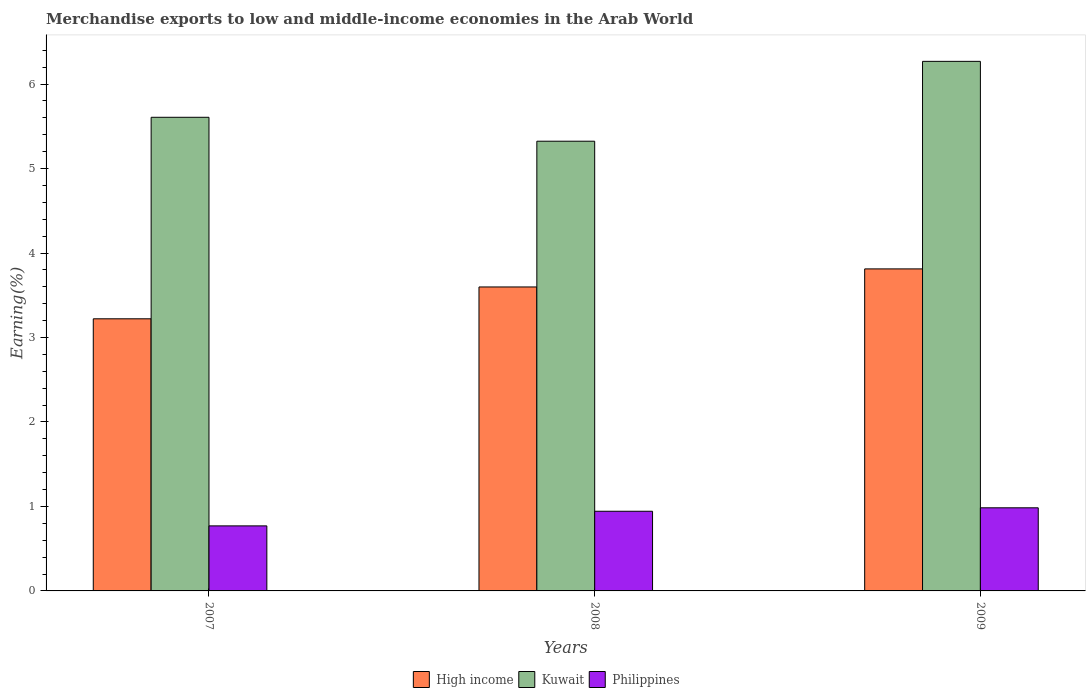How many groups of bars are there?
Provide a short and direct response. 3. How many bars are there on the 3rd tick from the left?
Give a very brief answer. 3. What is the percentage of amount earned from merchandise exports in Philippines in 2008?
Your answer should be compact. 0.94. Across all years, what is the maximum percentage of amount earned from merchandise exports in High income?
Keep it short and to the point. 3.81. Across all years, what is the minimum percentage of amount earned from merchandise exports in High income?
Offer a very short reply. 3.22. In which year was the percentage of amount earned from merchandise exports in High income maximum?
Give a very brief answer. 2009. In which year was the percentage of amount earned from merchandise exports in High income minimum?
Make the answer very short. 2007. What is the total percentage of amount earned from merchandise exports in Philippines in the graph?
Your response must be concise. 2.7. What is the difference between the percentage of amount earned from merchandise exports in Kuwait in 2008 and that in 2009?
Keep it short and to the point. -0.95. What is the difference between the percentage of amount earned from merchandise exports in High income in 2007 and the percentage of amount earned from merchandise exports in Kuwait in 2009?
Your answer should be compact. -3.05. What is the average percentage of amount earned from merchandise exports in Philippines per year?
Make the answer very short. 0.9. In the year 2009, what is the difference between the percentage of amount earned from merchandise exports in Kuwait and percentage of amount earned from merchandise exports in High income?
Keep it short and to the point. 2.46. What is the ratio of the percentage of amount earned from merchandise exports in Philippines in 2008 to that in 2009?
Provide a succinct answer. 0.96. Is the difference between the percentage of amount earned from merchandise exports in Kuwait in 2007 and 2009 greater than the difference between the percentage of amount earned from merchandise exports in High income in 2007 and 2009?
Your answer should be very brief. No. What is the difference between the highest and the second highest percentage of amount earned from merchandise exports in Kuwait?
Offer a very short reply. 0.66. What is the difference between the highest and the lowest percentage of amount earned from merchandise exports in Philippines?
Give a very brief answer. 0.21. In how many years, is the percentage of amount earned from merchandise exports in High income greater than the average percentage of amount earned from merchandise exports in High income taken over all years?
Provide a short and direct response. 2. What does the 2nd bar from the right in 2009 represents?
Ensure brevity in your answer.  Kuwait. How many bars are there?
Ensure brevity in your answer.  9. Does the graph contain grids?
Ensure brevity in your answer.  No. How many legend labels are there?
Your answer should be very brief. 3. What is the title of the graph?
Keep it short and to the point. Merchandise exports to low and middle-income economies in the Arab World. What is the label or title of the Y-axis?
Your response must be concise. Earning(%). What is the Earning(%) of High income in 2007?
Provide a short and direct response. 3.22. What is the Earning(%) of Kuwait in 2007?
Give a very brief answer. 5.61. What is the Earning(%) of Philippines in 2007?
Keep it short and to the point. 0.77. What is the Earning(%) of High income in 2008?
Provide a short and direct response. 3.6. What is the Earning(%) in Kuwait in 2008?
Your response must be concise. 5.32. What is the Earning(%) of Philippines in 2008?
Your response must be concise. 0.94. What is the Earning(%) in High income in 2009?
Provide a short and direct response. 3.81. What is the Earning(%) of Kuwait in 2009?
Make the answer very short. 6.27. What is the Earning(%) of Philippines in 2009?
Make the answer very short. 0.98. Across all years, what is the maximum Earning(%) of High income?
Offer a terse response. 3.81. Across all years, what is the maximum Earning(%) in Kuwait?
Your response must be concise. 6.27. Across all years, what is the maximum Earning(%) of Philippines?
Provide a succinct answer. 0.98. Across all years, what is the minimum Earning(%) of High income?
Provide a short and direct response. 3.22. Across all years, what is the minimum Earning(%) of Kuwait?
Your answer should be compact. 5.32. Across all years, what is the minimum Earning(%) in Philippines?
Provide a short and direct response. 0.77. What is the total Earning(%) in High income in the graph?
Provide a short and direct response. 10.63. What is the total Earning(%) in Kuwait in the graph?
Make the answer very short. 17.2. What is the total Earning(%) in Philippines in the graph?
Your response must be concise. 2.7. What is the difference between the Earning(%) of High income in 2007 and that in 2008?
Offer a very short reply. -0.38. What is the difference between the Earning(%) in Kuwait in 2007 and that in 2008?
Your answer should be very brief. 0.28. What is the difference between the Earning(%) of Philippines in 2007 and that in 2008?
Give a very brief answer. -0.17. What is the difference between the Earning(%) of High income in 2007 and that in 2009?
Your answer should be compact. -0.59. What is the difference between the Earning(%) in Kuwait in 2007 and that in 2009?
Offer a very short reply. -0.66. What is the difference between the Earning(%) in Philippines in 2007 and that in 2009?
Provide a short and direct response. -0.21. What is the difference between the Earning(%) in High income in 2008 and that in 2009?
Provide a succinct answer. -0.21. What is the difference between the Earning(%) of Kuwait in 2008 and that in 2009?
Your answer should be very brief. -0.95. What is the difference between the Earning(%) in Philippines in 2008 and that in 2009?
Your response must be concise. -0.04. What is the difference between the Earning(%) in High income in 2007 and the Earning(%) in Kuwait in 2008?
Give a very brief answer. -2.1. What is the difference between the Earning(%) in High income in 2007 and the Earning(%) in Philippines in 2008?
Provide a succinct answer. 2.28. What is the difference between the Earning(%) of Kuwait in 2007 and the Earning(%) of Philippines in 2008?
Offer a terse response. 4.66. What is the difference between the Earning(%) of High income in 2007 and the Earning(%) of Kuwait in 2009?
Your answer should be very brief. -3.05. What is the difference between the Earning(%) of High income in 2007 and the Earning(%) of Philippines in 2009?
Your answer should be compact. 2.24. What is the difference between the Earning(%) of Kuwait in 2007 and the Earning(%) of Philippines in 2009?
Your response must be concise. 4.62. What is the difference between the Earning(%) of High income in 2008 and the Earning(%) of Kuwait in 2009?
Give a very brief answer. -2.67. What is the difference between the Earning(%) of High income in 2008 and the Earning(%) of Philippines in 2009?
Keep it short and to the point. 2.61. What is the difference between the Earning(%) in Kuwait in 2008 and the Earning(%) in Philippines in 2009?
Provide a succinct answer. 4.34. What is the average Earning(%) in High income per year?
Your answer should be compact. 3.54. What is the average Earning(%) of Kuwait per year?
Your response must be concise. 5.73. What is the average Earning(%) in Philippines per year?
Your response must be concise. 0.9. In the year 2007, what is the difference between the Earning(%) in High income and Earning(%) in Kuwait?
Your response must be concise. -2.39. In the year 2007, what is the difference between the Earning(%) in High income and Earning(%) in Philippines?
Keep it short and to the point. 2.45. In the year 2007, what is the difference between the Earning(%) of Kuwait and Earning(%) of Philippines?
Offer a terse response. 4.84. In the year 2008, what is the difference between the Earning(%) of High income and Earning(%) of Kuwait?
Keep it short and to the point. -1.73. In the year 2008, what is the difference between the Earning(%) in High income and Earning(%) in Philippines?
Your answer should be compact. 2.66. In the year 2008, what is the difference between the Earning(%) of Kuwait and Earning(%) of Philippines?
Provide a succinct answer. 4.38. In the year 2009, what is the difference between the Earning(%) in High income and Earning(%) in Kuwait?
Make the answer very short. -2.46. In the year 2009, what is the difference between the Earning(%) of High income and Earning(%) of Philippines?
Offer a very short reply. 2.83. In the year 2009, what is the difference between the Earning(%) of Kuwait and Earning(%) of Philippines?
Keep it short and to the point. 5.29. What is the ratio of the Earning(%) of High income in 2007 to that in 2008?
Keep it short and to the point. 0.9. What is the ratio of the Earning(%) in Kuwait in 2007 to that in 2008?
Your answer should be compact. 1.05. What is the ratio of the Earning(%) in Philippines in 2007 to that in 2008?
Provide a short and direct response. 0.82. What is the ratio of the Earning(%) in High income in 2007 to that in 2009?
Ensure brevity in your answer.  0.84. What is the ratio of the Earning(%) of Kuwait in 2007 to that in 2009?
Your answer should be compact. 0.89. What is the ratio of the Earning(%) in Philippines in 2007 to that in 2009?
Keep it short and to the point. 0.78. What is the ratio of the Earning(%) in High income in 2008 to that in 2009?
Give a very brief answer. 0.94. What is the ratio of the Earning(%) of Kuwait in 2008 to that in 2009?
Give a very brief answer. 0.85. What is the ratio of the Earning(%) in Philippines in 2008 to that in 2009?
Your answer should be very brief. 0.96. What is the difference between the highest and the second highest Earning(%) of High income?
Offer a very short reply. 0.21. What is the difference between the highest and the second highest Earning(%) of Kuwait?
Offer a terse response. 0.66. What is the difference between the highest and the second highest Earning(%) in Philippines?
Your response must be concise. 0.04. What is the difference between the highest and the lowest Earning(%) of High income?
Make the answer very short. 0.59. What is the difference between the highest and the lowest Earning(%) in Kuwait?
Ensure brevity in your answer.  0.95. What is the difference between the highest and the lowest Earning(%) of Philippines?
Provide a succinct answer. 0.21. 